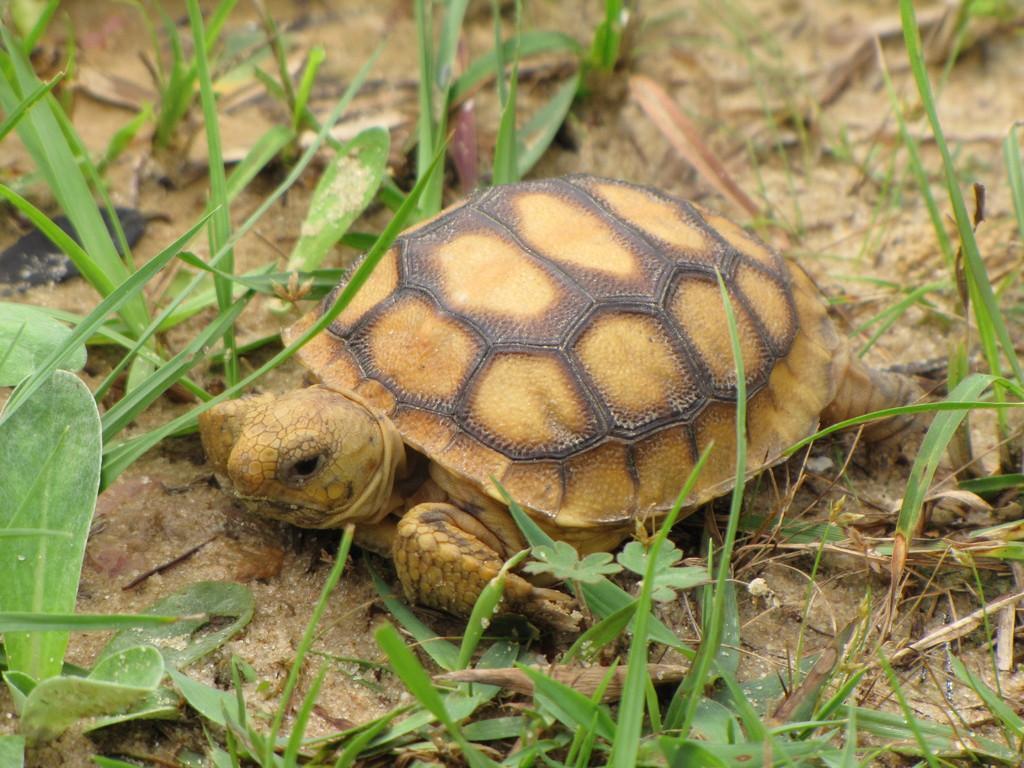Can you describe this image briefly? In this picture we can see a turtle and grass. 